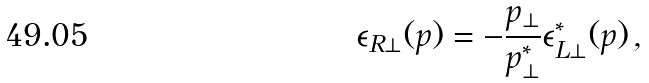<formula> <loc_0><loc_0><loc_500><loc_500>\epsilon _ { R \perp } ( p ) = - { \frac { p _ { \perp } } { p _ { \perp } ^ { * } } } \epsilon _ { L \perp } ^ { * } ( p ) \, ,</formula> 